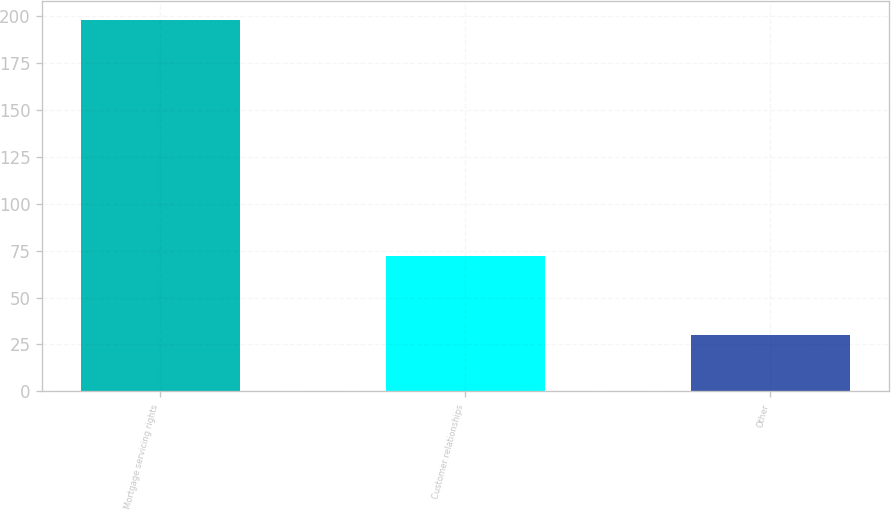Convert chart to OTSL. <chart><loc_0><loc_0><loc_500><loc_500><bar_chart><fcel>Mortgage servicing rights<fcel>Customer relationships<fcel>Other<nl><fcel>198<fcel>72<fcel>30<nl></chart> 